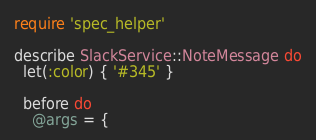<code> <loc_0><loc_0><loc_500><loc_500><_Ruby_>require 'spec_helper'

describe SlackService::NoteMessage do
  let(:color) { '#345' }

  before do
    @args = {</code> 